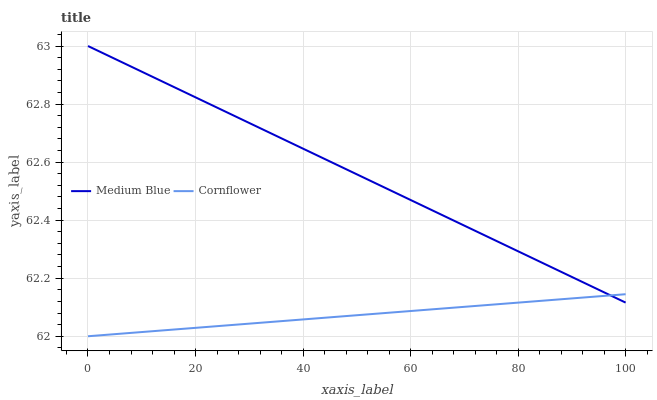Does Cornflower have the minimum area under the curve?
Answer yes or no. Yes. Does Medium Blue have the maximum area under the curve?
Answer yes or no. Yes. Does Medium Blue have the minimum area under the curve?
Answer yes or no. No. Is Cornflower the smoothest?
Answer yes or no. Yes. Is Medium Blue the roughest?
Answer yes or no. Yes. Is Medium Blue the smoothest?
Answer yes or no. No. Does Cornflower have the lowest value?
Answer yes or no. Yes. Does Medium Blue have the lowest value?
Answer yes or no. No. Does Medium Blue have the highest value?
Answer yes or no. Yes. Does Medium Blue intersect Cornflower?
Answer yes or no. Yes. Is Medium Blue less than Cornflower?
Answer yes or no. No. Is Medium Blue greater than Cornflower?
Answer yes or no. No. 